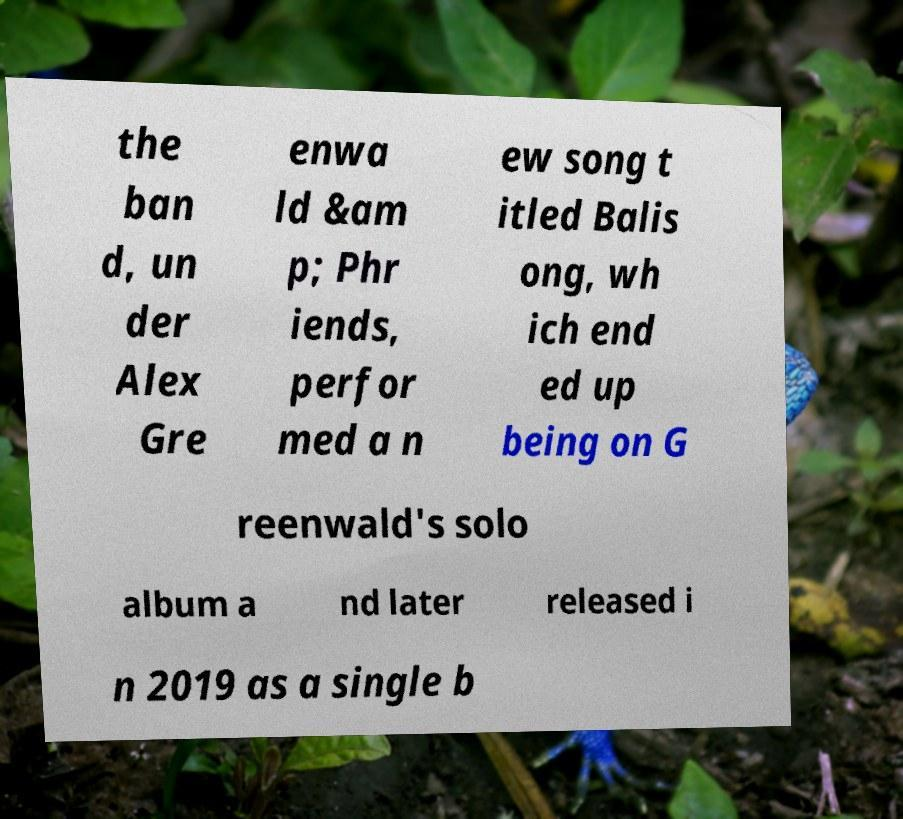Please read and relay the text visible in this image. What does it say? the ban d, un der Alex Gre enwa ld &am p; Phr iends, perfor med a n ew song t itled Balis ong, wh ich end ed up being on G reenwald's solo album a nd later released i n 2019 as a single b 